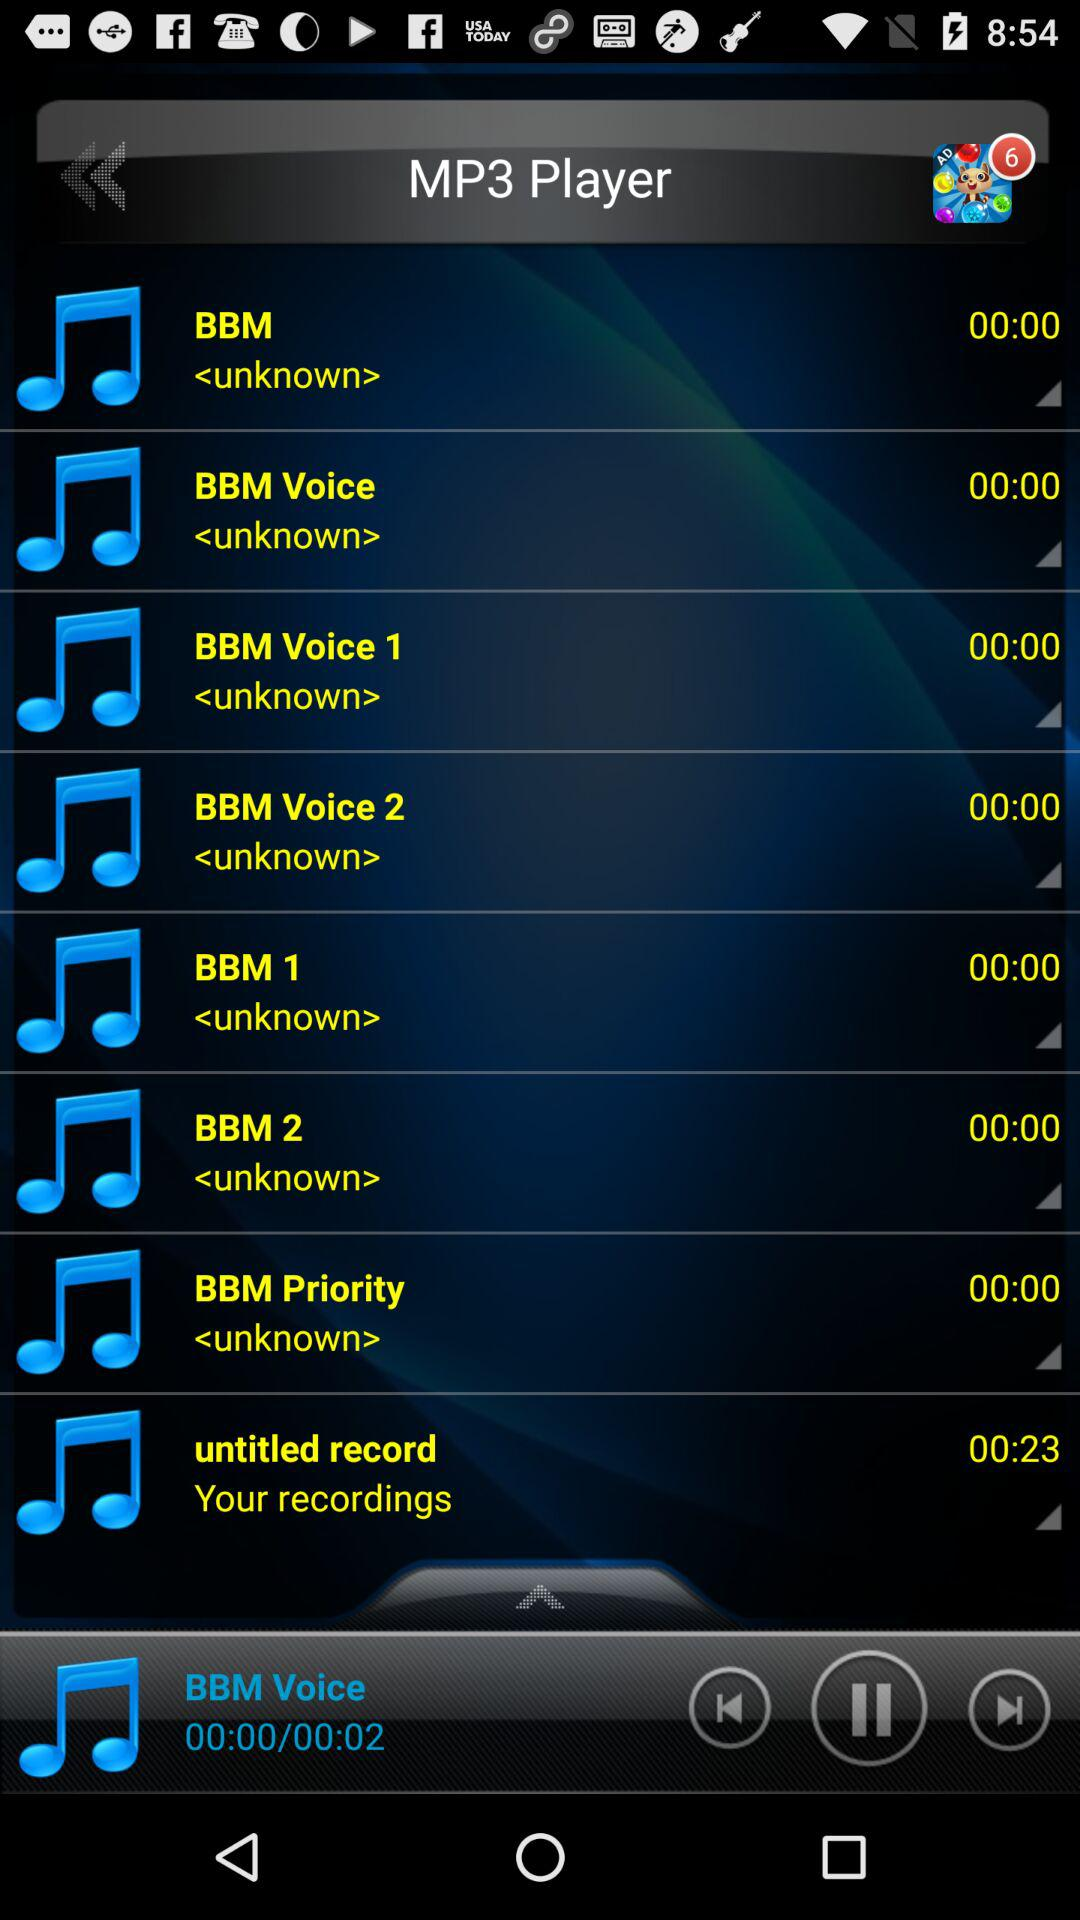What is the application name? The application name is "MP3 Player". 